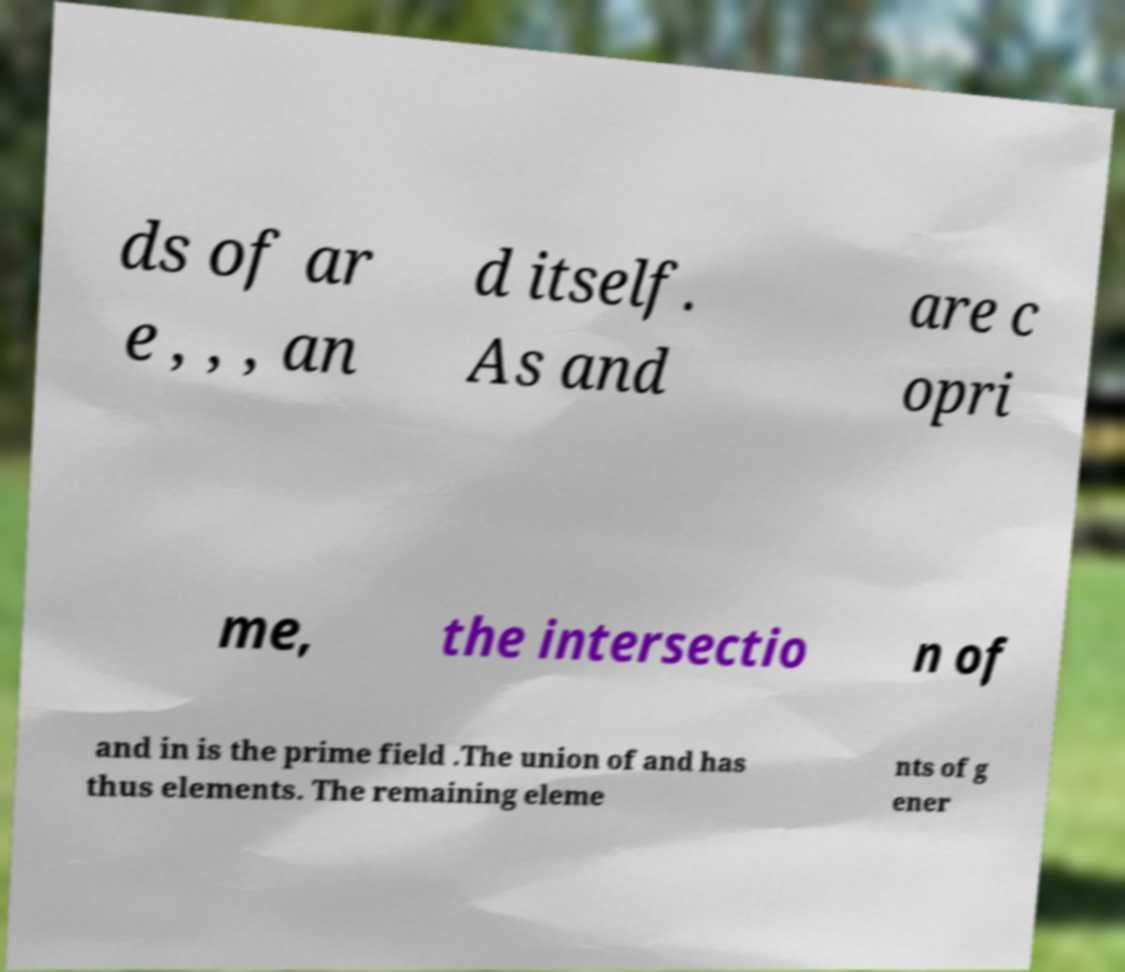What messages or text are displayed in this image? I need them in a readable, typed format. ds of ar e , , , an d itself. As and are c opri me, the intersectio n of and in is the prime field .The union of and has thus elements. The remaining eleme nts of g ener 